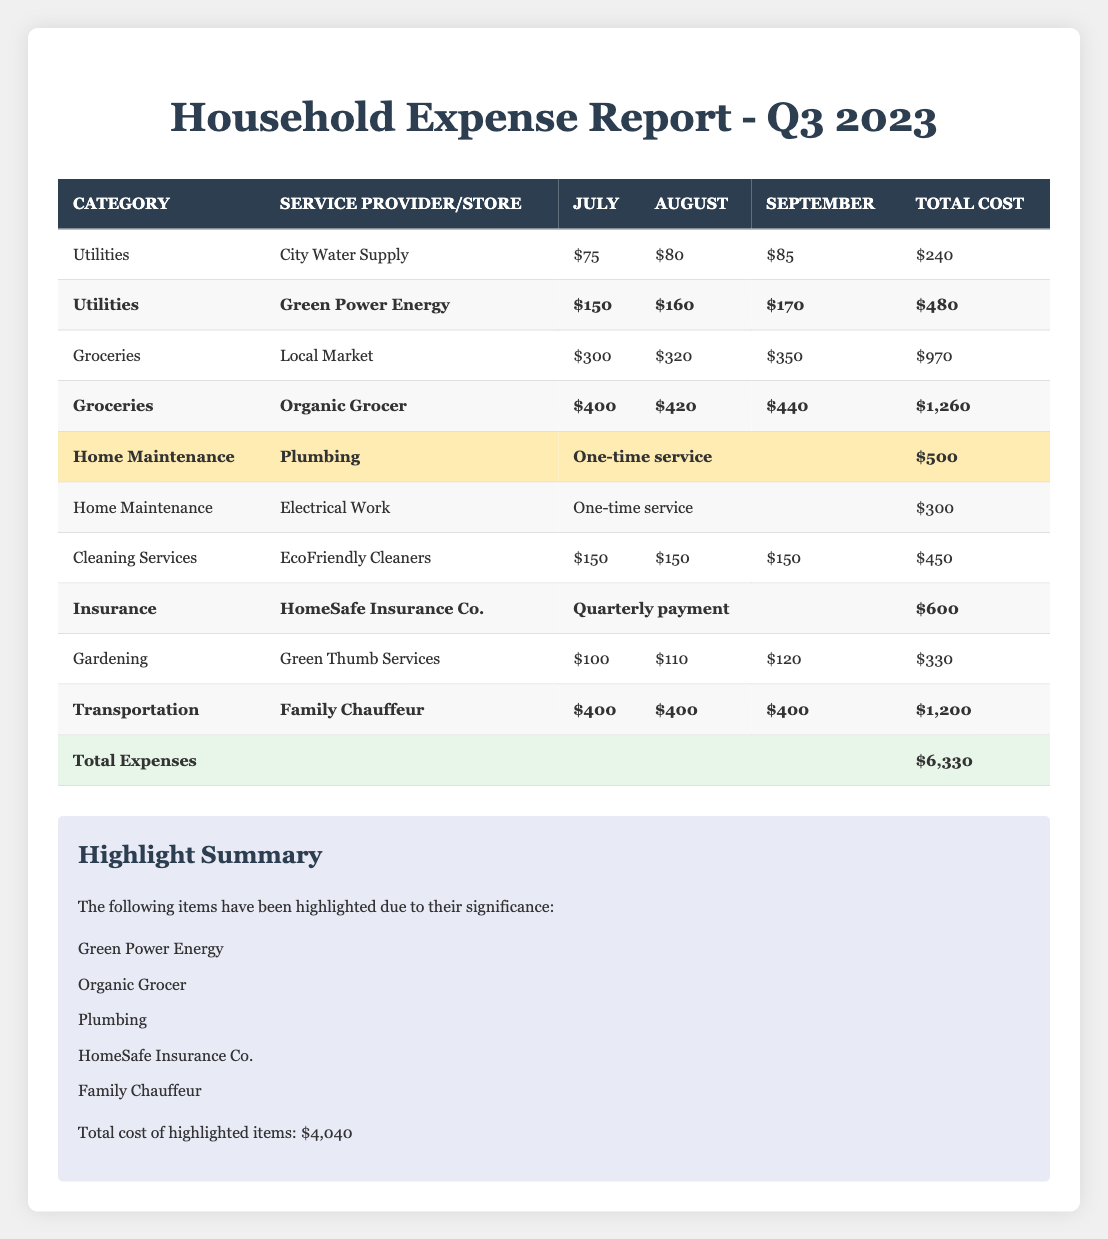What is the total cost of the highlighted items? The highlighted items in the table include Green Power Energy ($480), Organic Grocer ($1,260), Plumbing ($500), HomeSafe Insurance Co. ($600), and Family Chauffeur ($1,200). Adding these amounts gives us: $480 + $1,260 + $500 + $600 + $1,200 = $4,040.
Answer: $4,040 Which category has the highest total expense? The categories with total expenses are Utilities ($720, which includes City Water Supply and Green Power Energy), Groceries ($2,230, which includes Local Market and Organic Grocer), Home Maintenance ($800, which includes Plumbing and Electrical Work), Cleaning Services ($450), Insurance ($600), Gardening ($330), and Transportation ($1,200). The highest total expense is Groceries at $2,230.
Answer: Groceries Did we spend more on Utilities or Transportation? The total cost for Utilities is $720 (City Water Supply + Green Power Energy) and for Transportation it is $1,200 (Family Chauffeur). Since $1,200 (Transportation) is greater than $720 (Utilities), the answer is Transportation.
Answer: Transportation Which service provider had the highest single line item cost? Checking through the table, the costs are: City Water Supply ($240), Green Power Energy ($480), Local Market ($970), Organic Grocer ($1,260), Plumbing ($500), Electrical Work ($300), EcoFriendly Cleaners ($450), HomeSafe Insurance Co. ($600), Green Thumb Services ($330), and Family Chauffeur ($1,200). The highest single item cost is Family Chauffeur with $1,200.
Answer: Family Chauffeur What is the average monthly cost for the Green Power Energy service? The monthly costs for Green Power Energy are $150, $160, and $170. To find the average, add them: $150 + $160 + $170 = $480, then divide by 3 (number of months). So, $480 / 3 = $160.
Answer: $160 Is the total expense more than $5,000? The total expense reported is $4,650. Since $4,650 is less than $5,000, the answer is no.
Answer: No What is the difference in total expenses between the Groceries and Utilities categories? The total for Groceries is $2,230 and for Utilities it is $720. The difference is calculated by subtracting Utilities from Groceries: $2,230 - $720 = $1,510.
Answer: $1,510 How much was spent on Home Maintenance in total? There are two entries for Home Maintenance: Plumbing ($500) and Electrical Work ($300). Adding these amounts gives $500 + $300 = $800 for total Home Maintenance.
Answer: $800 Which highlighted expense has the highest cost, and what is that cost? The highlighted expenses are Green Power Energy ($480), Organic Grocer ($1,260), Plumbing ($500), HomeSafe Insurance Co. ($600), and Family Chauffeur ($1,200). The highest among these is Family Chauffeur at $1,200.
Answer: Family Chauffeur, $1,200 How many service providers or stores are listed under the Groceries category? There are two entries under Groceries: Local Market and Organic Grocer, making a total of 2.
Answer: 2 